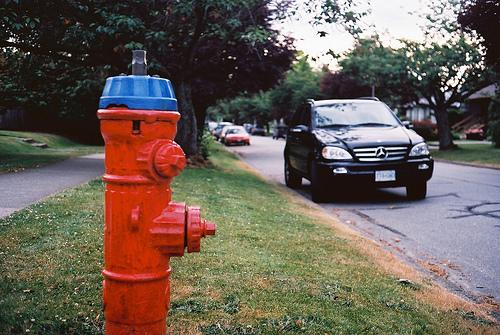Describe the image in a poetic way. A serene street with whispers of green trees and parked cars awaits, with colorful hydrants standing guard and houses tucked away from prying eyes. Mention 3 different objects in the image and their colors. There is a red and blue fire hydrant, a parked black vehicle, and a large green tree in the image. Provide a short description of the main objects in the image. There are green trees, grass, a red and blue fire hydrant, parked cars, houses, and a sidewalk in the image. What is the general atmosphere of the image? The general atmosphere of the image is peaceful, with a suburban neighborhood feel. What are the most vivid colors seen in the image? The most vivid colors are red, blue, green, black, and white. Describe the scene in the image as if you were there. I'm standing on a sidewalk near green trees, parked cars, a red and blue fire hydrant, and houses along the street. Create a descriptive sentence about the setting of the image. The image captures a typical suburban scene with green trees, colorful fire hydrants, parked cars along the streets, and quaint houses in the distance. Imagine you're giving a tour of the area, through a photograph, what do you see? I see a beautiful street lined with large green trees, parked cars, a red and blue fire hydrant, houses in the distance, and a well-kept sidewalk. Wear the eyes of a car enthusiast and describe the scene. A car enthusiast would notice the diversity of parked vehicles by the curb, some with unique features like reflections of tree leaves in the windows. What do you think a city planner would say about this scene? A city planner might comment on the well-maintained sidewalks, street parking, fire hydrant placement, and the greenery throughout the neighborhood. 